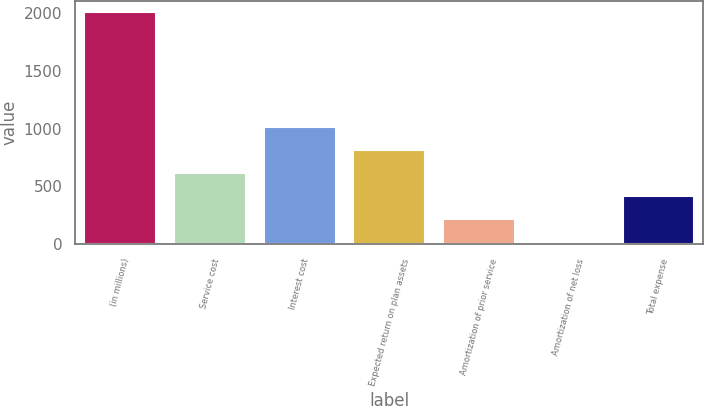Convert chart to OTSL. <chart><loc_0><loc_0><loc_500><loc_500><bar_chart><fcel>(in millions)<fcel>Service cost<fcel>Interest cost<fcel>Expected return on plan assets<fcel>Amortization of prior service<fcel>Amortization of net loss<fcel>Total expense<nl><fcel>2008<fcel>613.6<fcel>1012<fcel>812.8<fcel>215.2<fcel>16<fcel>414.4<nl></chart> 